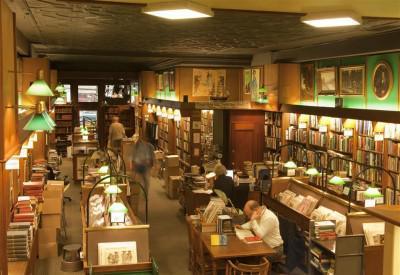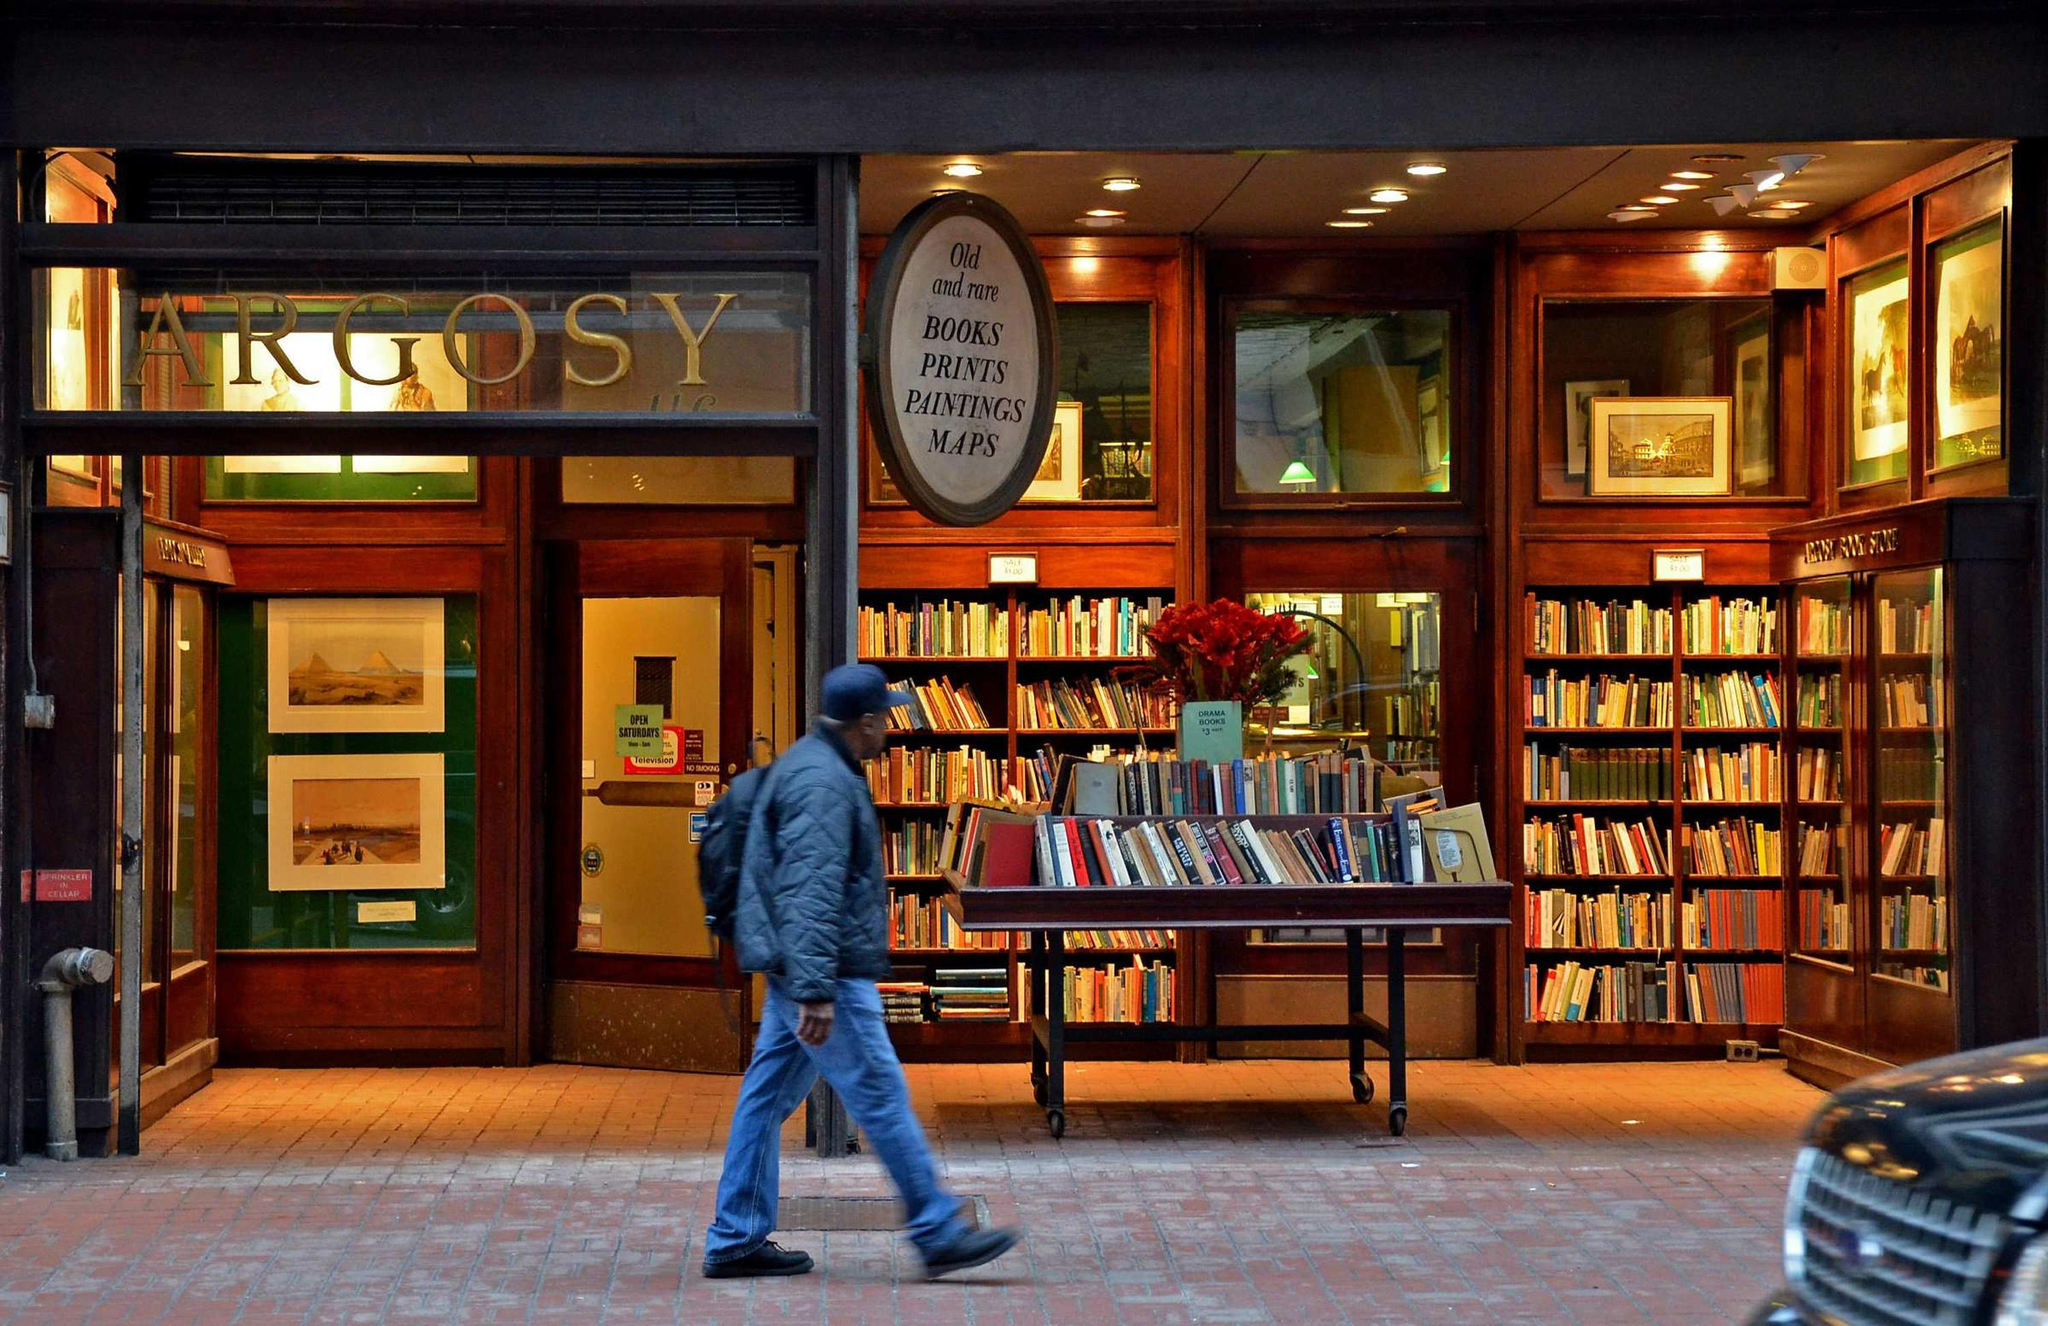The first image is the image on the left, the second image is the image on the right. Assess this claim about the two images: "The right image includes green reading lamps suspended from black arches.". Correct or not? Answer yes or no. No. 